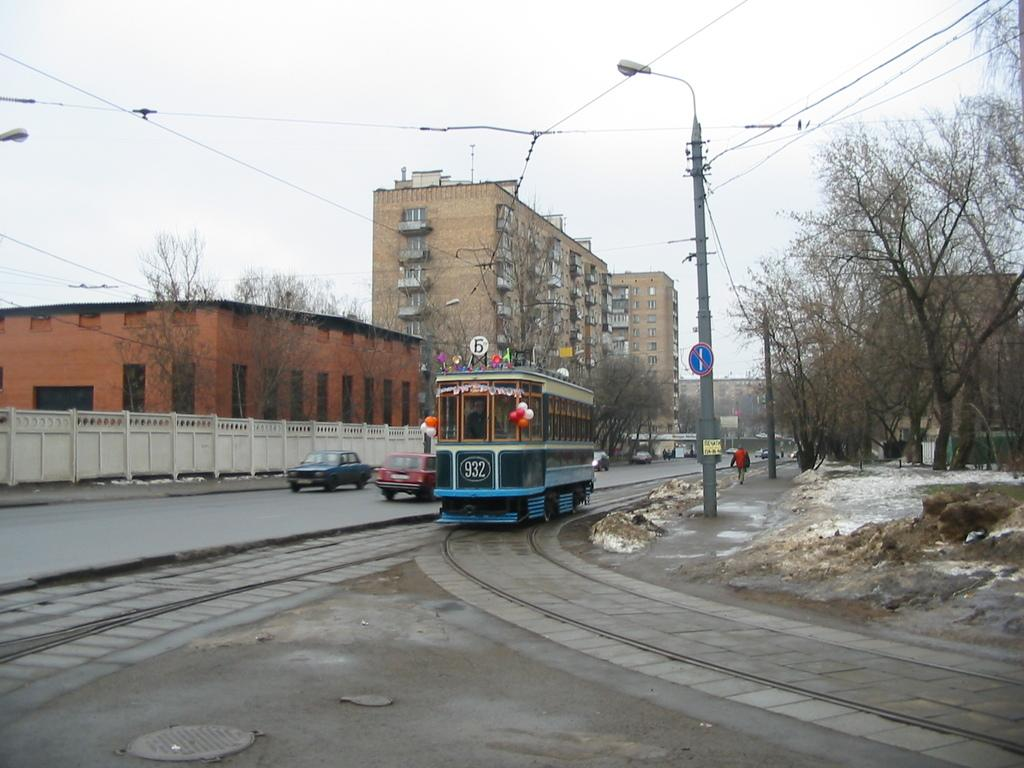<image>
Offer a succinct explanation of the picture presented. Railway car number 932 heads down the tracks next to a red car. 